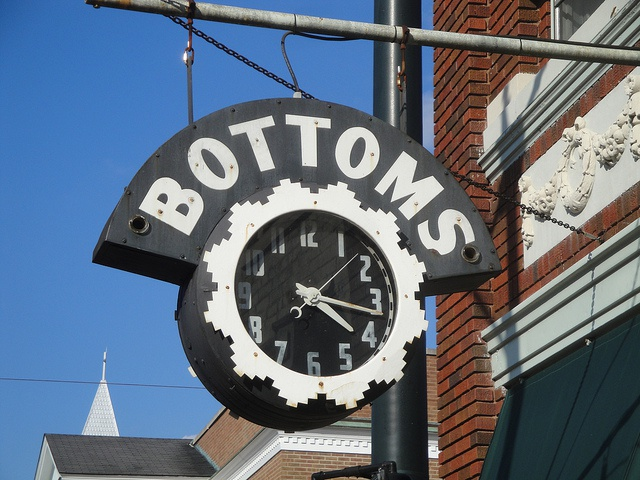Describe the objects in this image and their specific colors. I can see a clock in blue, black, lightgray, gray, and darkgray tones in this image. 